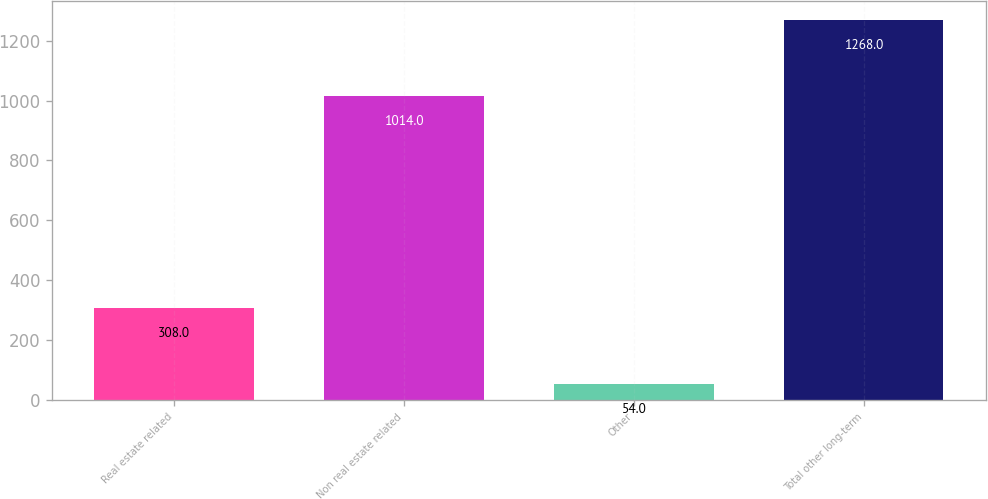Convert chart to OTSL. <chart><loc_0><loc_0><loc_500><loc_500><bar_chart><fcel>Real estate related<fcel>Non real estate related<fcel>Other<fcel>Total other long-term<nl><fcel>308<fcel>1014<fcel>54<fcel>1268<nl></chart> 